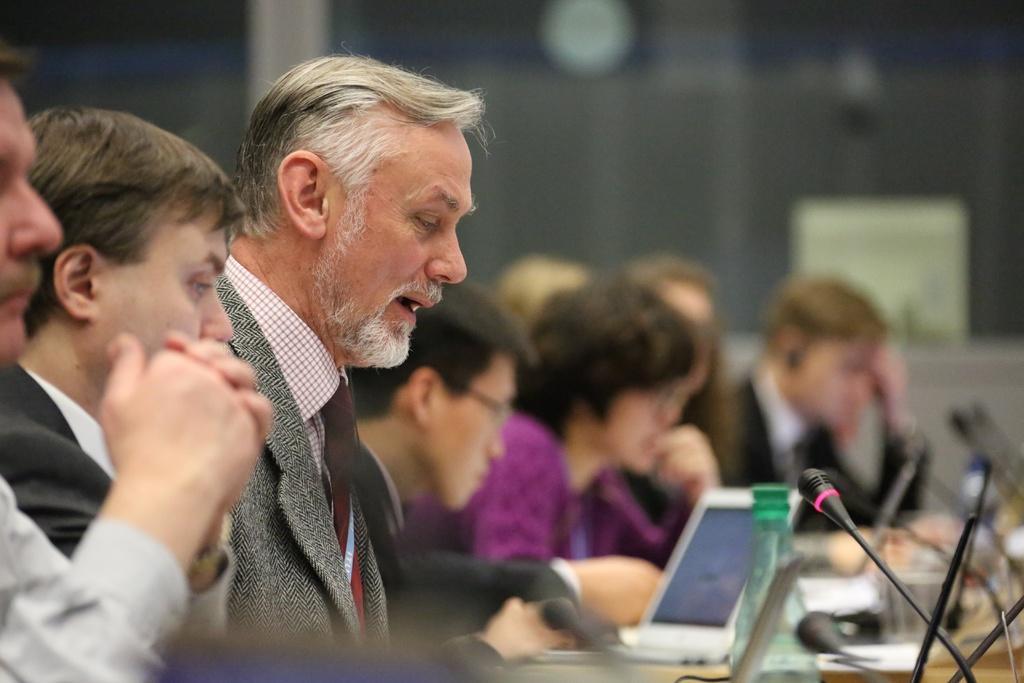Please provide a concise description of this image. In this picture I can see group of people are sitting in front of a table. On the table i can see microphones, bottle and other objects. This man is wearing tie, suit and shirt. 